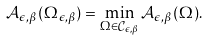<formula> <loc_0><loc_0><loc_500><loc_500>\mathcal { A } _ { \epsilon , \beta } ( \Omega _ { \epsilon , \beta } ) = \min _ { \Omega \in \mathcal { C } _ { \epsilon , \beta } } \mathcal { A } _ { \epsilon , \beta } ( \Omega ) .</formula> 